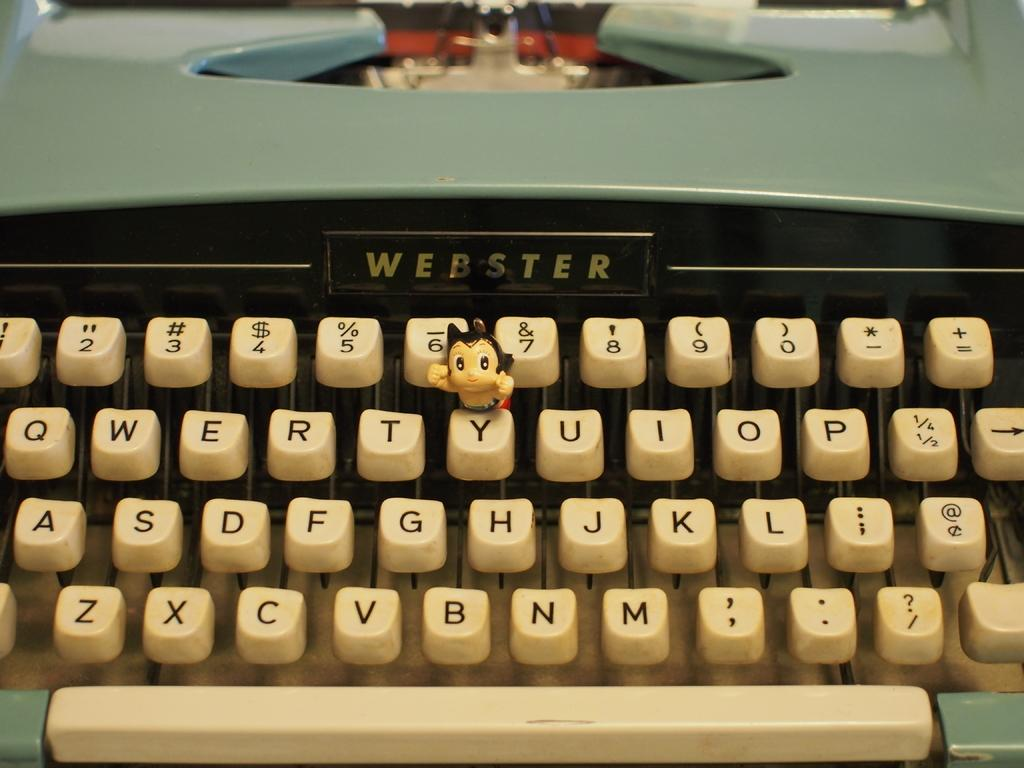<image>
Offer a succinct explanation of the picture presented. A closeup on a Webster typewriter shows a figurine placed between the 6 and Y keys. 